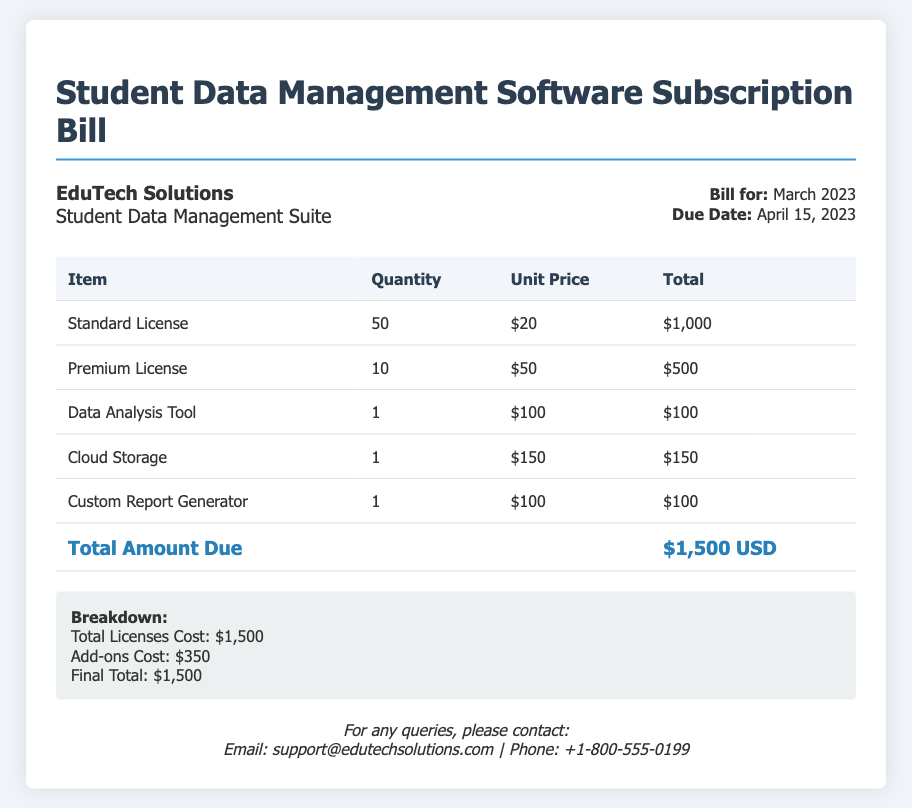What is the total amount due? The total amount due is listed in the document's footer as $1,500 USD.
Answer: $1,500 USD How many standard licenses are included? The document specifies a quantity of 50 for standard licenses.
Answer: 50 What is the unit price for a premium license? The unit price for a premium license is listed as $50.
Answer: $50 What is the due date for this bill? The due date is provided in the bill information as April 15, 2023.
Answer: April 15, 2023 How much do the add-ons cost? The breakdown mentions that the add-ons cost a total of $350.
Answer: $350 How many total licenses are included in the bill? The total licenses are 50 standard + 10 premium = 60 licenses.
Answer: 60 What additional feature has a price of $100? The Data Analysis Tool and Custom Report Generator both have a price of $100 according to the table.
Answer: Data Analysis Tool, Custom Report Generator Who is the billing company? The company listed at the top of the document is EduTech Solutions.
Answer: EduTech Solutions What is the cost of cloud storage? The cost of cloud storage is mentioned as $150 in the document.
Answer: $150 